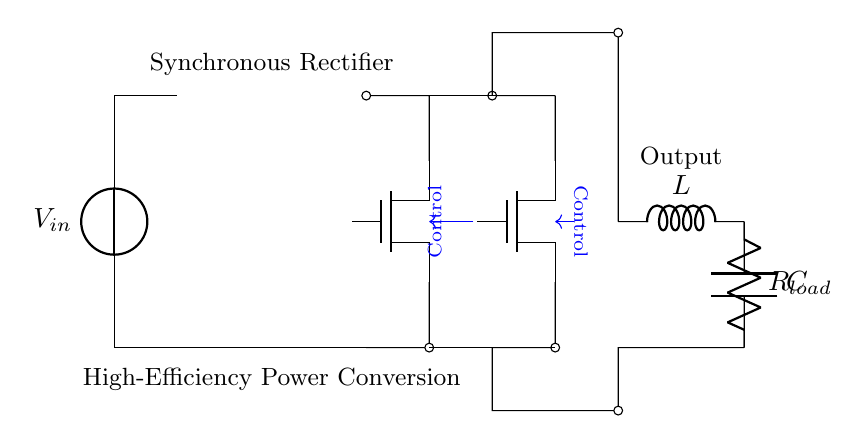What is the type of rectifier used in this circuit? The circuit uses a synchronous rectifier, indicated by the presence of the transistors labeled S1 and S2.
Answer: Synchronous rectifier What components are used in the output section of the circuit? The output section contains an inductor labeled L, a capacitor labeled C, and a load resistor labeled R load.
Answer: L, C, R load How many transistors are present in the rectifier circuit? There are two transistors, S1 and S2, used for rectification as indicated in the circuit diagram.
Answer: 2 What is the function of the transformer in this circuit? The transformer steps up or steps down the input voltage before rectification, which is crucial for power conversion efficiency.
Answer: Voltage conversion What do the blue arrows in the diagram indicate? The blue arrows represent control signals that manage the operation of the synchronous rectifier transistors S1 and S2, ensuring they are activated at the correct times.
Answer: Control signals How does this synchronous rectifier improve power conversion efficiency? It minimizes voltage drop during conduction, allowing for lower power losses compared to conventional diodes, thus enhancing overall efficiency.
Answer: Minimized voltage drop 